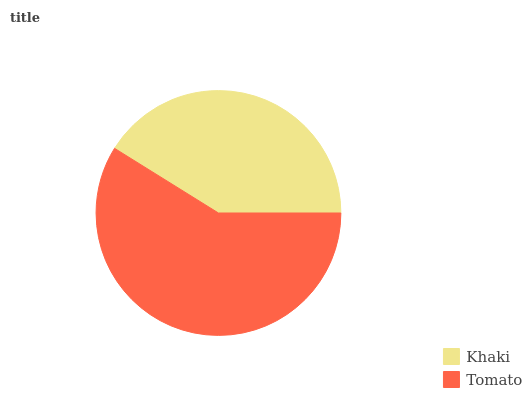Is Khaki the minimum?
Answer yes or no. Yes. Is Tomato the maximum?
Answer yes or no. Yes. Is Tomato the minimum?
Answer yes or no. No. Is Tomato greater than Khaki?
Answer yes or no. Yes. Is Khaki less than Tomato?
Answer yes or no. Yes. Is Khaki greater than Tomato?
Answer yes or no. No. Is Tomato less than Khaki?
Answer yes or no. No. Is Tomato the high median?
Answer yes or no. Yes. Is Khaki the low median?
Answer yes or no. Yes. Is Khaki the high median?
Answer yes or no. No. Is Tomato the low median?
Answer yes or no. No. 